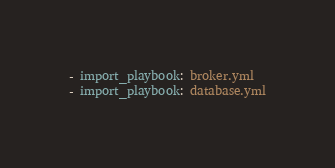<code> <loc_0><loc_0><loc_500><loc_500><_YAML_>- import_playbook: broker.yml
- import_playbook: database.yml
</code> 